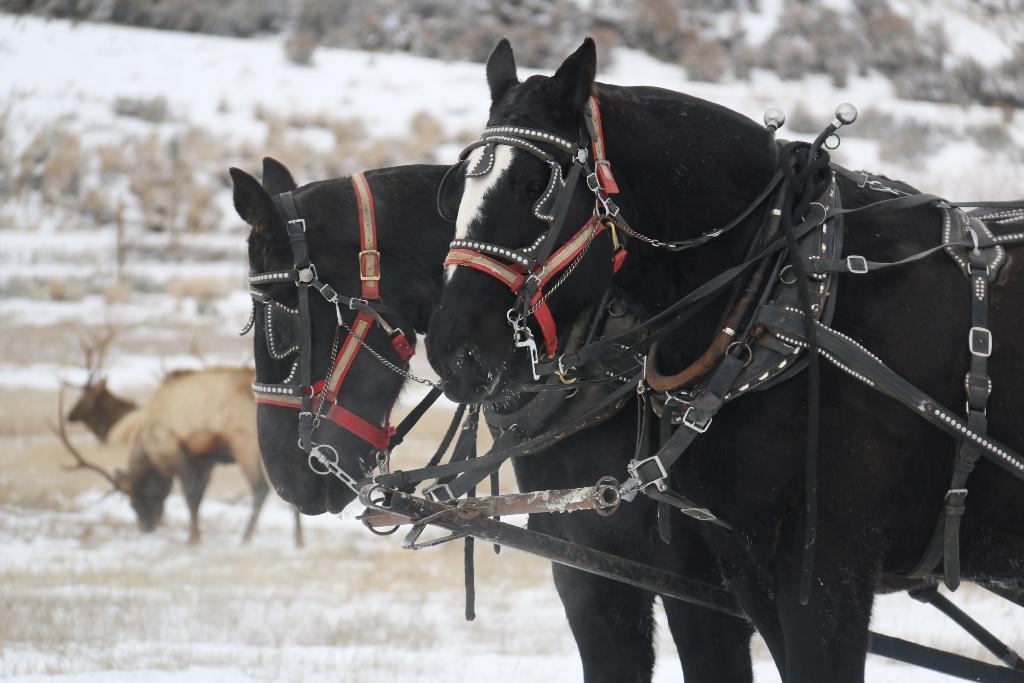Can you describe this image briefly? In the center of the image we can see two horses. And we can see belts are attached to the horses. In the background, we can see snow, animals and a few other objects. 